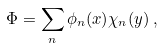<formula> <loc_0><loc_0><loc_500><loc_500>\Phi = \sum _ { n } \phi _ { n } ( x ) \chi _ { n } ( y ) \, ,</formula> 